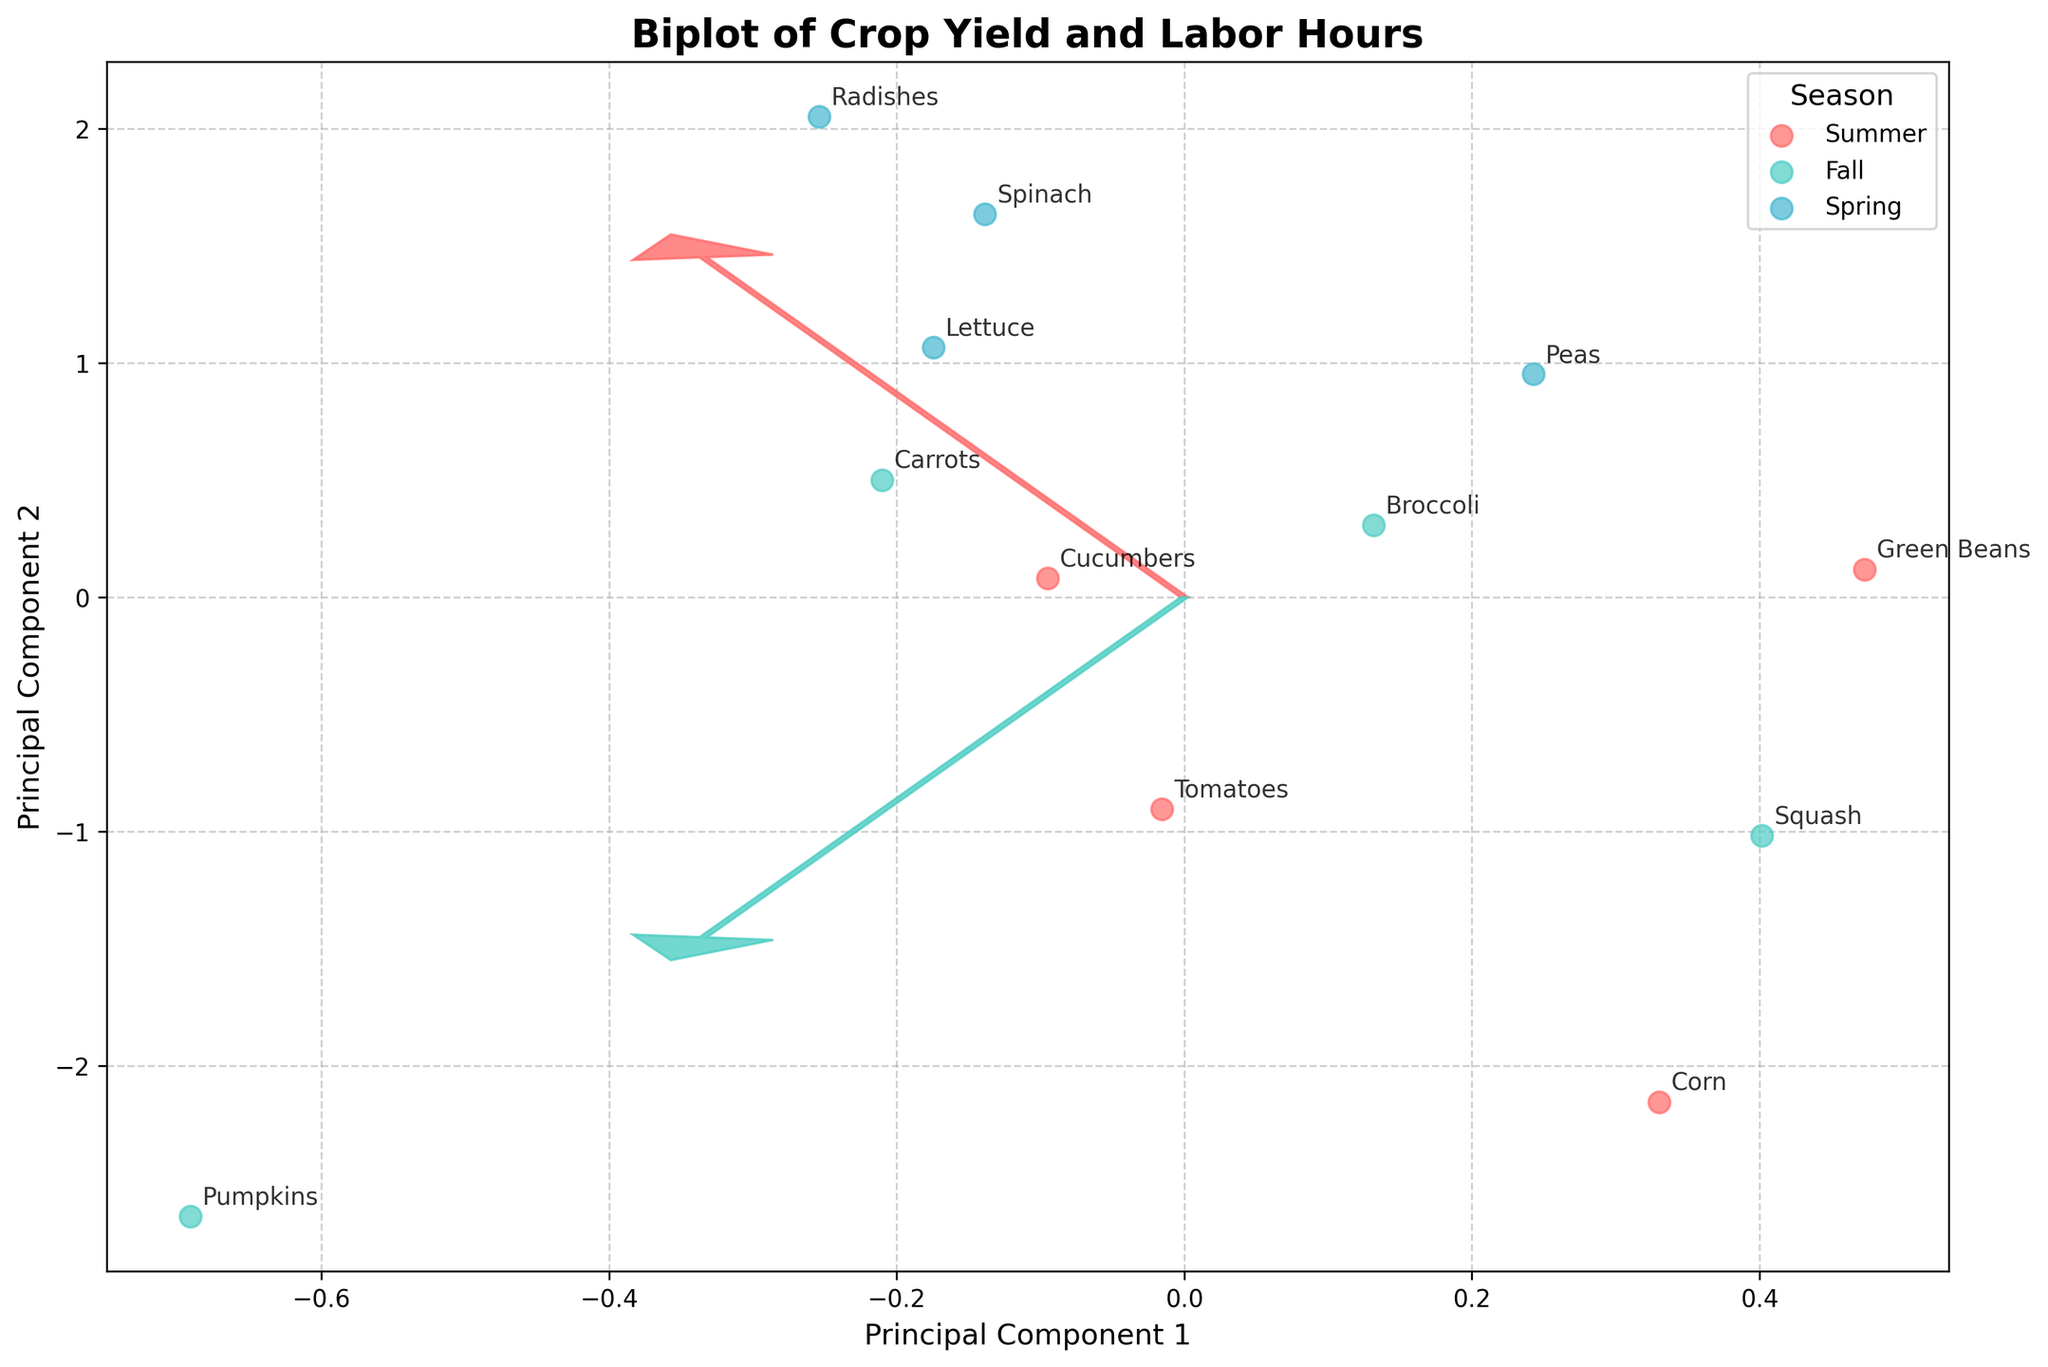What is the title of the biplot? The title of the biplot can be seen at the top of the figure in bold and slightly larger font compared to the axis labels.
Answer: Biplot of Crop Yield and Labor Hours How many different seasons are represented in the plot? The legend on the plot indicates how many unique seasons are represented; each season is marked by a different color.
Answer: 4 Which crop required the most labor hours? By looking at the data points and annotations on the plot, find the crop that is positioned farthest along the axis representing labor hours.
Answer: Corn Which season has the highest cluster concentration of data points on the left side of the plot? Identify the color corresponding to the left-most cluster in the plot, then refer to the legend to determine the season.
Answer: Spring Which crops are planted in the summer? Look for data points in the plot marked with the color representing summer, as indicated by the legend, and read the annotations for those data points.
Answer: Tomatoes, Cucumbers, Green Beans, Corn What is the range of the two principal components on the x and y axes? Examine the x-axis and y-axis limits that the projected data points span across in the plot.
Answer: -3 to 3 Which feature vector points more towards the data points with higher yield? Observe the direction of the arrows (feature vectors) and check which arrow is more aligned with the data points that belong to crops with higher yield values.
Answer: Yield_kg vector Are the crops in the fall season closer to the center or more spread out in the plot? By analyzing the positions of the data points marked with the color representing fall, see if they cluster around the center of the plot or are spread out.
Answer: More spread out Which crop is positioned farthest in the positive direction of Principal Component 1? Look for the data point farthest to the right along the x-axis, and read the corresponding crop label.
Answer: Pumpkins Is there a general trend between labor hours and crop yield? Evaluate the direction and spread of the data points relative to the principal components to determine any observable trend between labor hours and crop yield.
Answer: Higher labor hours generally align with higher yield 